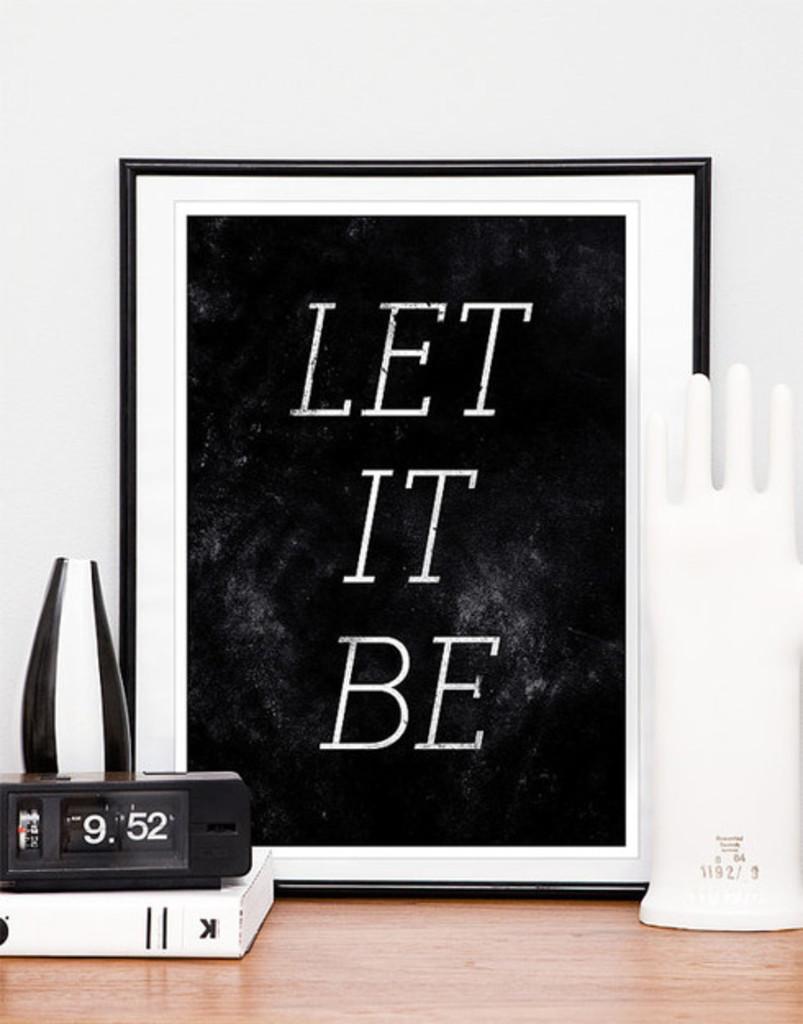What time does the clock say it is?
Your answer should be compact. 9:52. What does the sign say to do?
Provide a short and direct response. Let it be. 